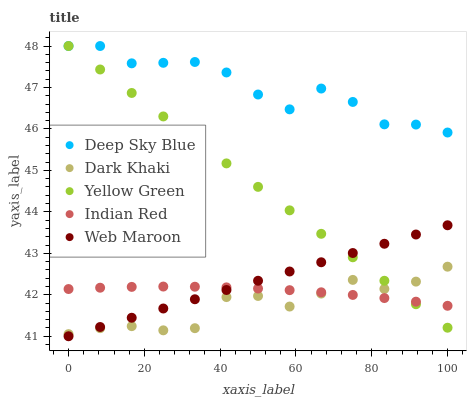Does Dark Khaki have the minimum area under the curve?
Answer yes or no. Yes. Does Deep Sky Blue have the maximum area under the curve?
Answer yes or no. Yes. Does Indian Red have the minimum area under the curve?
Answer yes or no. No. Does Indian Red have the maximum area under the curve?
Answer yes or no. No. Is Web Maroon the smoothest?
Answer yes or no. Yes. Is Deep Sky Blue the roughest?
Answer yes or no. Yes. Is Indian Red the smoothest?
Answer yes or no. No. Is Indian Red the roughest?
Answer yes or no. No. Does Web Maroon have the lowest value?
Answer yes or no. Yes. Does Indian Red have the lowest value?
Answer yes or no. No. Does Deep Sky Blue have the highest value?
Answer yes or no. Yes. Does Web Maroon have the highest value?
Answer yes or no. No. Is Dark Khaki less than Deep Sky Blue?
Answer yes or no. Yes. Is Deep Sky Blue greater than Indian Red?
Answer yes or no. Yes. Does Yellow Green intersect Web Maroon?
Answer yes or no. Yes. Is Yellow Green less than Web Maroon?
Answer yes or no. No. Is Yellow Green greater than Web Maroon?
Answer yes or no. No. Does Dark Khaki intersect Deep Sky Blue?
Answer yes or no. No. 